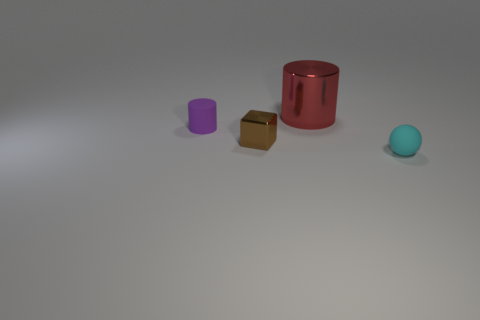Is the color of the small matte thing that is behind the tiny cyan object the same as the metal thing in front of the small purple matte cylinder?
Offer a terse response. No. What shape is the cyan object?
Make the answer very short. Sphere. Are there more red metallic things that are to the left of the small cyan matte ball than tiny yellow shiny cubes?
Provide a succinct answer. Yes. What shape is the tiny rubber object on the right side of the large red object?
Keep it short and to the point. Sphere. How many other things are the same shape as the big red object?
Your answer should be compact. 1. Is the cylinder that is to the left of the big metallic thing made of the same material as the red object?
Offer a terse response. No. Are there an equal number of blocks that are in front of the matte sphere and metallic blocks on the left side of the brown metal object?
Give a very brief answer. Yes. What is the size of the matte thing that is to the left of the cyan ball?
Provide a succinct answer. Small. Are there any large red things that have the same material as the purple cylinder?
Offer a terse response. No. There is a matte thing that is behind the small cyan matte thing; does it have the same color as the large shiny object?
Provide a short and direct response. No. 